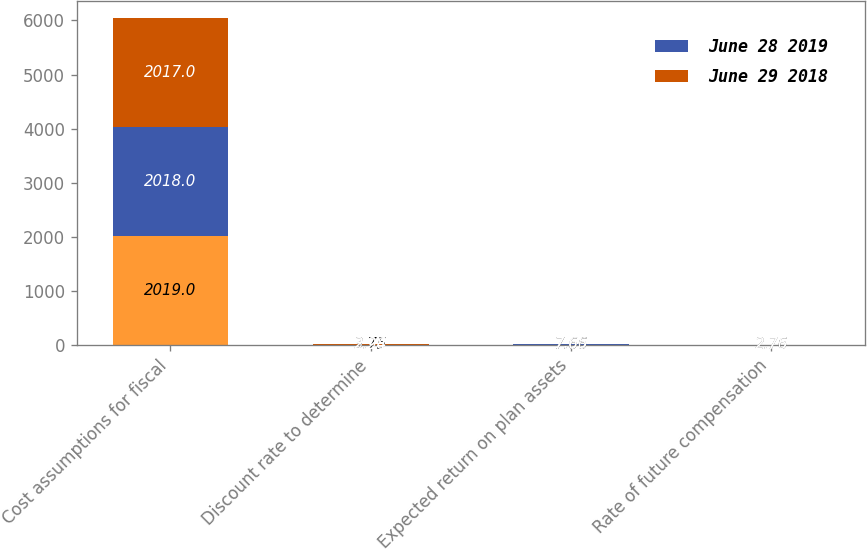Convert chart. <chart><loc_0><loc_0><loc_500><loc_500><stacked_bar_chart><ecel><fcel>Cost assumptions for fiscal<fcel>Discount rate to determine<fcel>Expected return on plan assets<fcel>Rate of future compensation<nl><fcel>nan<fcel>2019<fcel>3.75<fcel>7.66<fcel>2.76<nl><fcel>June 28 2019<fcel>2018<fcel>3.28<fcel>7.66<fcel>2.76<nl><fcel>June 29 2018<fcel>2017<fcel>2.94<fcel>7.65<fcel>2.75<nl></chart> 